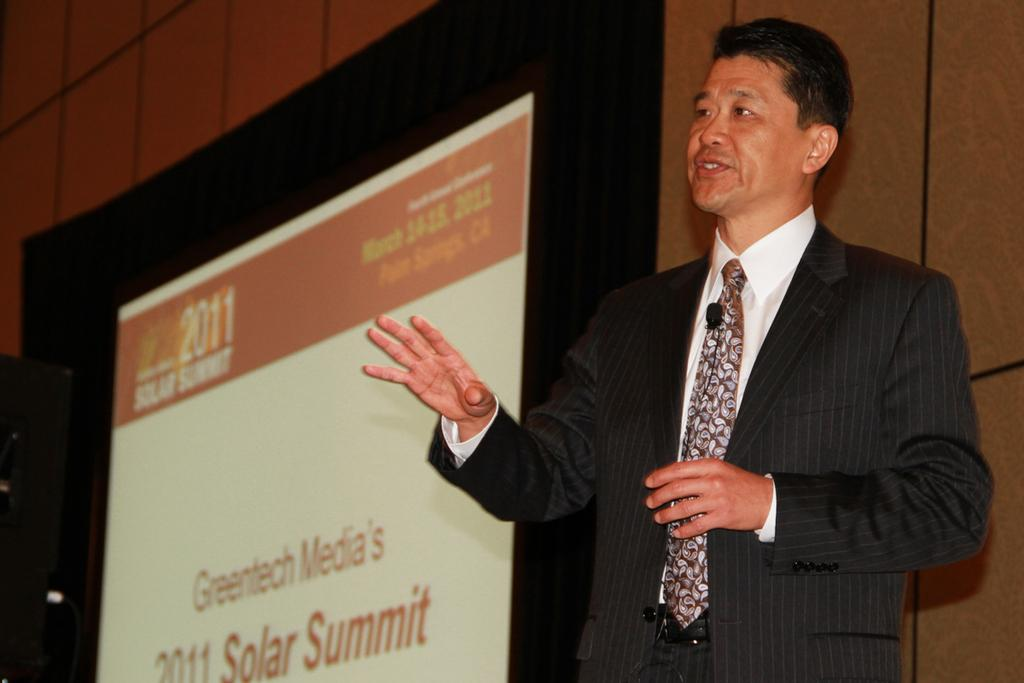What is the man in the image doing? The man is standing and talking in the image. What is the man wearing in the image? The man is wearing a shirt, a tie, and a suit in the image. What is the setting of the image? The image appears to be displayed on a screen, and there is a wall visible in the image. What type of pies is the man eating in the image? There is no indication in the image that the man is eating any pies, so it cannot be determined from the picture. 